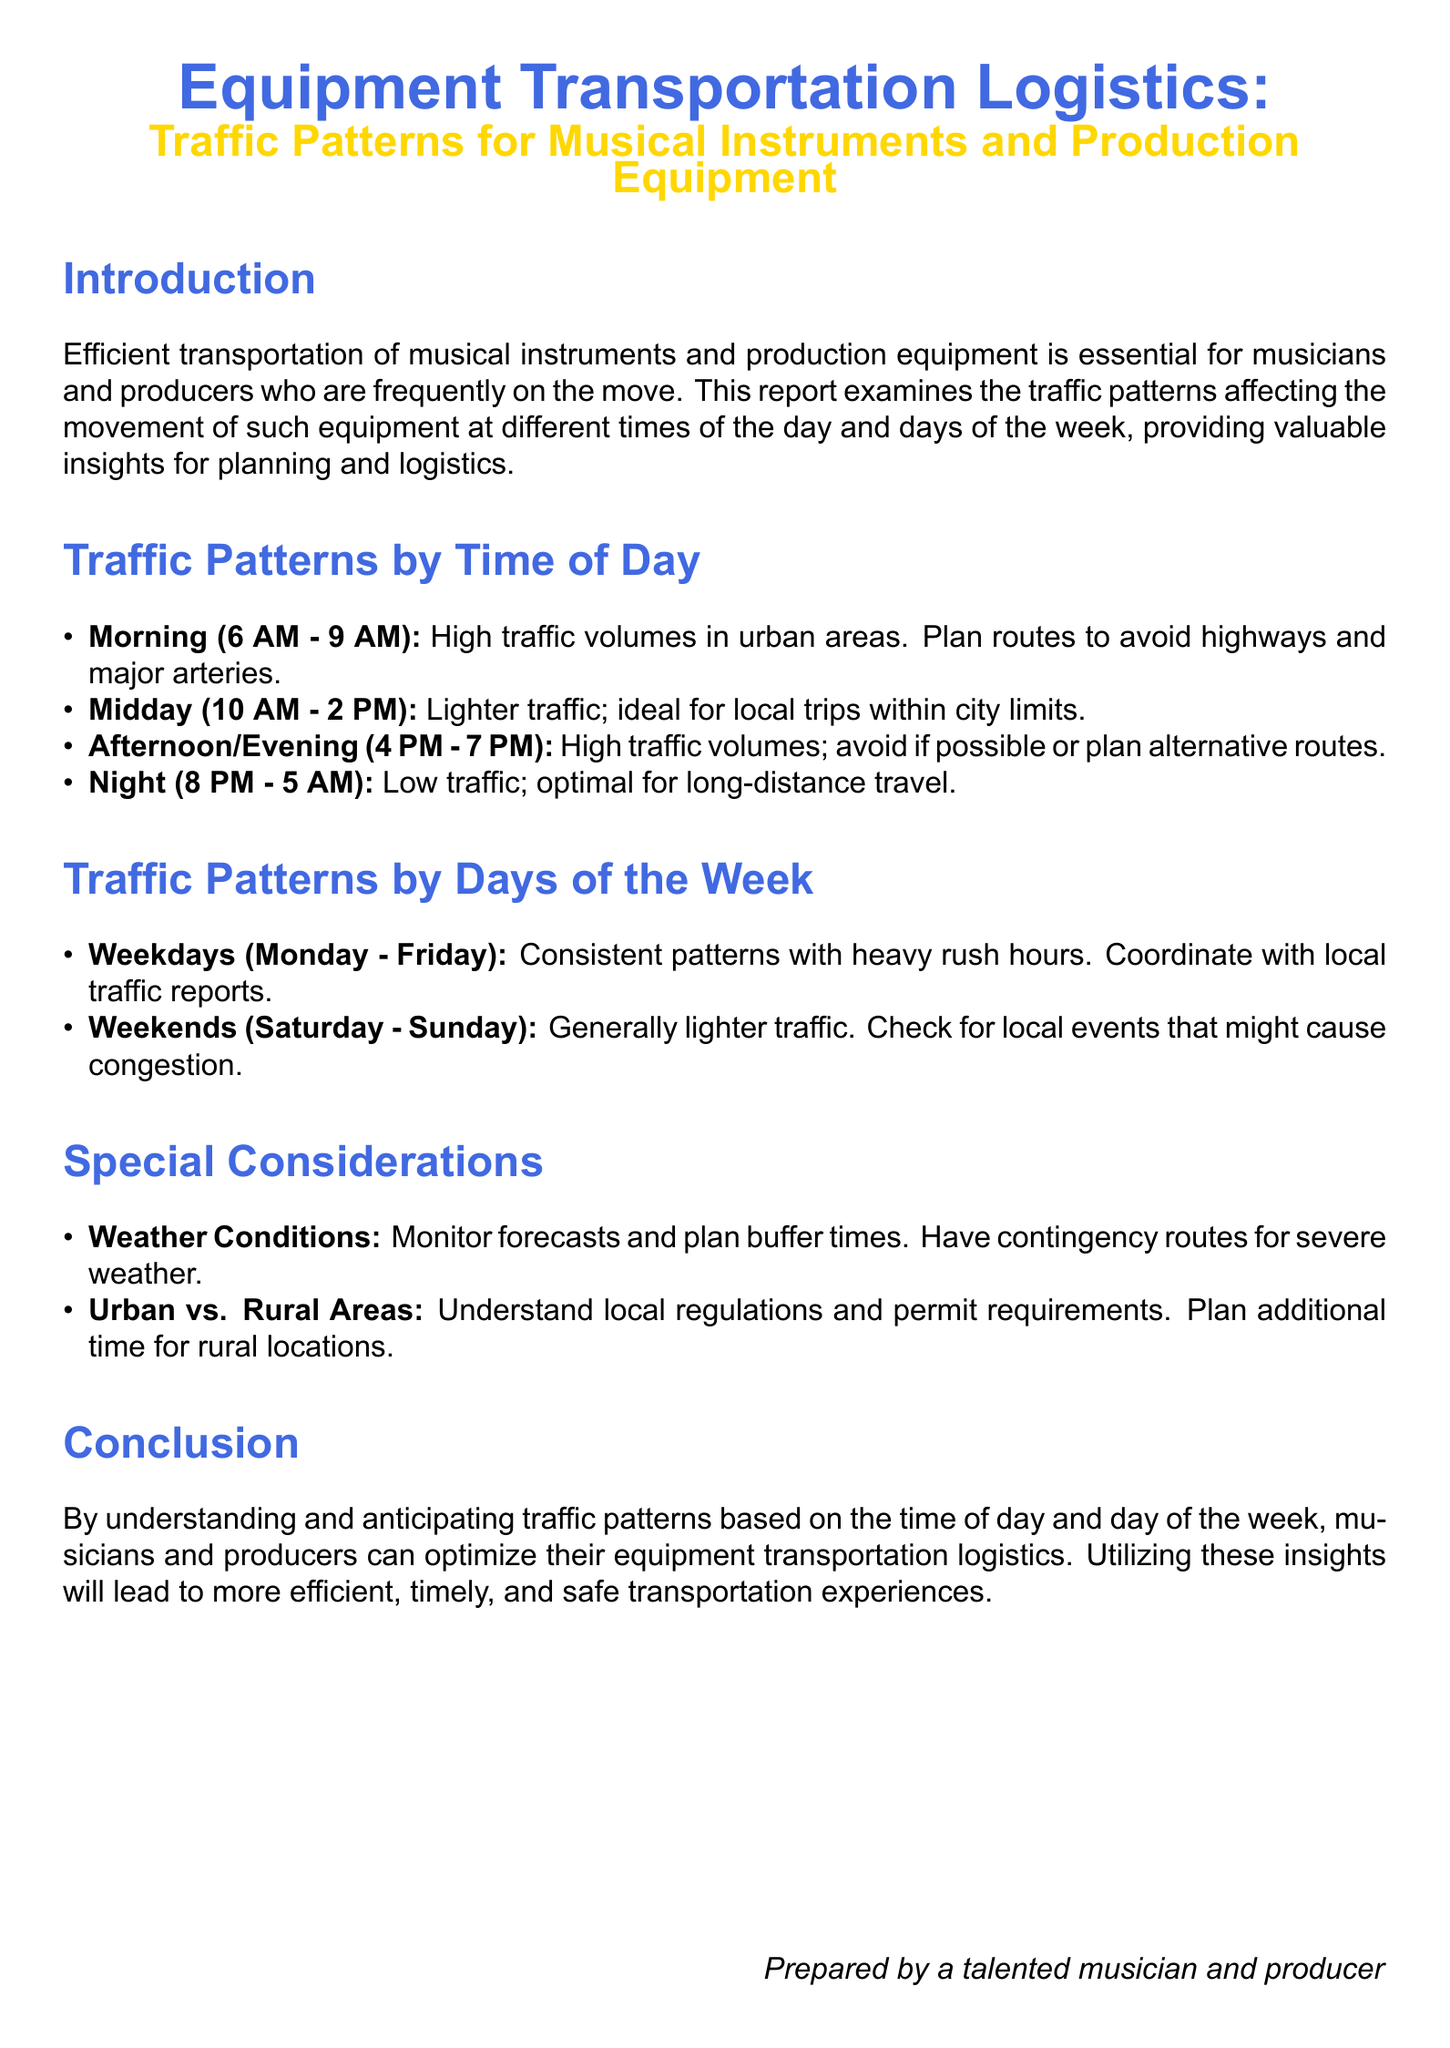What are the optimal travel hours for long-distance travel? The report states that night hours from 8 PM to 5 AM are optimal for long-distance travel due to low traffic.
Answer: 8 PM - 5 AM What is the traffic pattern during midday? The document explains that midday (10 AM - 2 PM) has lighter traffic, making it ideal for local trips within city limits.
Answer: Lighter traffic When does heavy traffic occur on weekdays? The report outlines that consistent patterns with heavy rush hours happen on weekdays, specifically from 6 AM to 9 AM and 4 PM to 7 PM.
Answer: 6 AM - 9 AM and 4 PM - 7 PM What should be monitored to accommodate for unexpected delays? The report mentions that weather conditions should be monitored to plan buffer times for transportation.
Answer: Weather conditions What days have generally lighter traffic? According to the report, weekends, specifically Saturday and Sunday, typically have lighter traffic.
Answer: Saturday - Sunday What is advised to check for on weekends? The document suggests checking for local events that might cause congestion during weekends.
Answer: Local events What should be considered in rural areas? The report recommends understanding local regulations and permit requirements in rural areas.
Answer: Local regulations and permit requirements Which traffic pattern is noted in the morning? The report indicates that high traffic volumes are common in urban areas during the morning from 6 AM to 9 AM.
Answer: High traffic volumes Which time frame is ideal for local trips? The midday time frame from 10 AM to 2 PM is noted as ideal for local trips within city limits.
Answer: 10 AM - 2 PM 